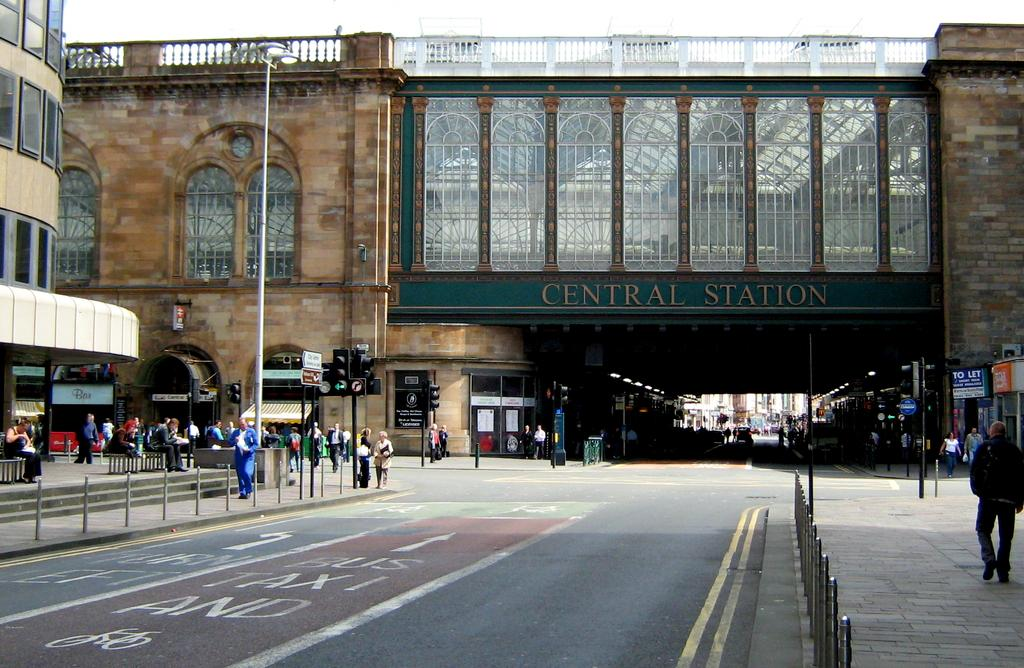What type of pathway is visible in the image? There is a road in the image. What structures can be seen in the image? There are buildings in the image. What objects are present alongside the road? There are poles in the image. What are the people in the image doing? People are walking on a walkway in the image. What is the condition of the sky in the image? The sky is clear in the image. What type of sock is the country wearing in the image? There is no country or sock present in the image. How many men are visible in the image? There is no information about men in the image; it only mentions people walking on a walkway. 